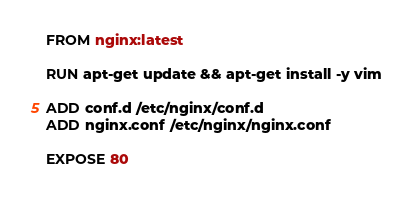<code> <loc_0><loc_0><loc_500><loc_500><_Dockerfile_>FROM nginx:latest

RUN apt-get update && apt-get install -y vim

ADD conf.d /etc/nginx/conf.d
ADD nginx.conf /etc/nginx/nginx.conf

EXPOSE 80
</code> 